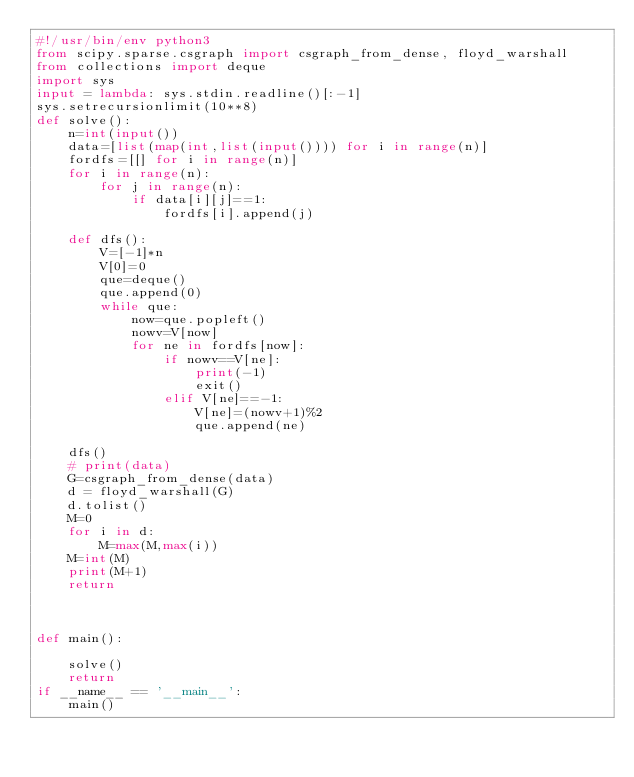<code> <loc_0><loc_0><loc_500><loc_500><_Python_>#!/usr/bin/env python3
from scipy.sparse.csgraph import csgraph_from_dense, floyd_warshall
from collections import deque
import sys
input = lambda: sys.stdin.readline()[:-1]
sys.setrecursionlimit(10**8)
def solve():
    n=int(input())
    data=[list(map(int,list(input()))) for i in range(n)]
    fordfs=[[] for i in range(n)]
    for i in range(n):
        for j in range(n):
            if data[i][j]==1:
                fordfs[i].append(j)

    def dfs():
        V=[-1]*n
        V[0]=0
        que=deque()
        que.append(0)
        while que:
            now=que.popleft()
            nowv=V[now]
            for ne in fordfs[now]:
                if nowv==V[ne]:
                    print(-1)
                    exit()
                elif V[ne]==-1:
                    V[ne]=(nowv+1)%2
                    que.append(ne)
    
    dfs()
    # print(data)
    G=csgraph_from_dense(data)
    d = floyd_warshall(G)
    d.tolist()
    M=0
    for i in d:
        M=max(M,max(i))
    M=int(M)
    print(M+1)
    return



def main():

    solve()
    return
if __name__ == '__main__':
    main()
</code> 